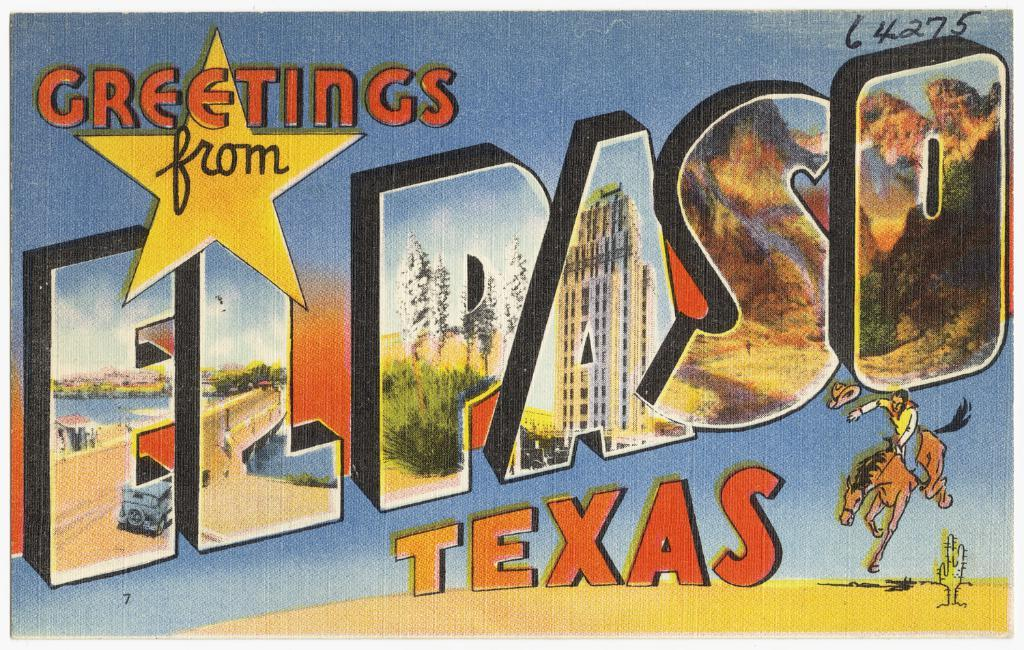<image>
Relay a brief, clear account of the picture shown. a postard from el paso texas with a man riding a horse at the bottom right 